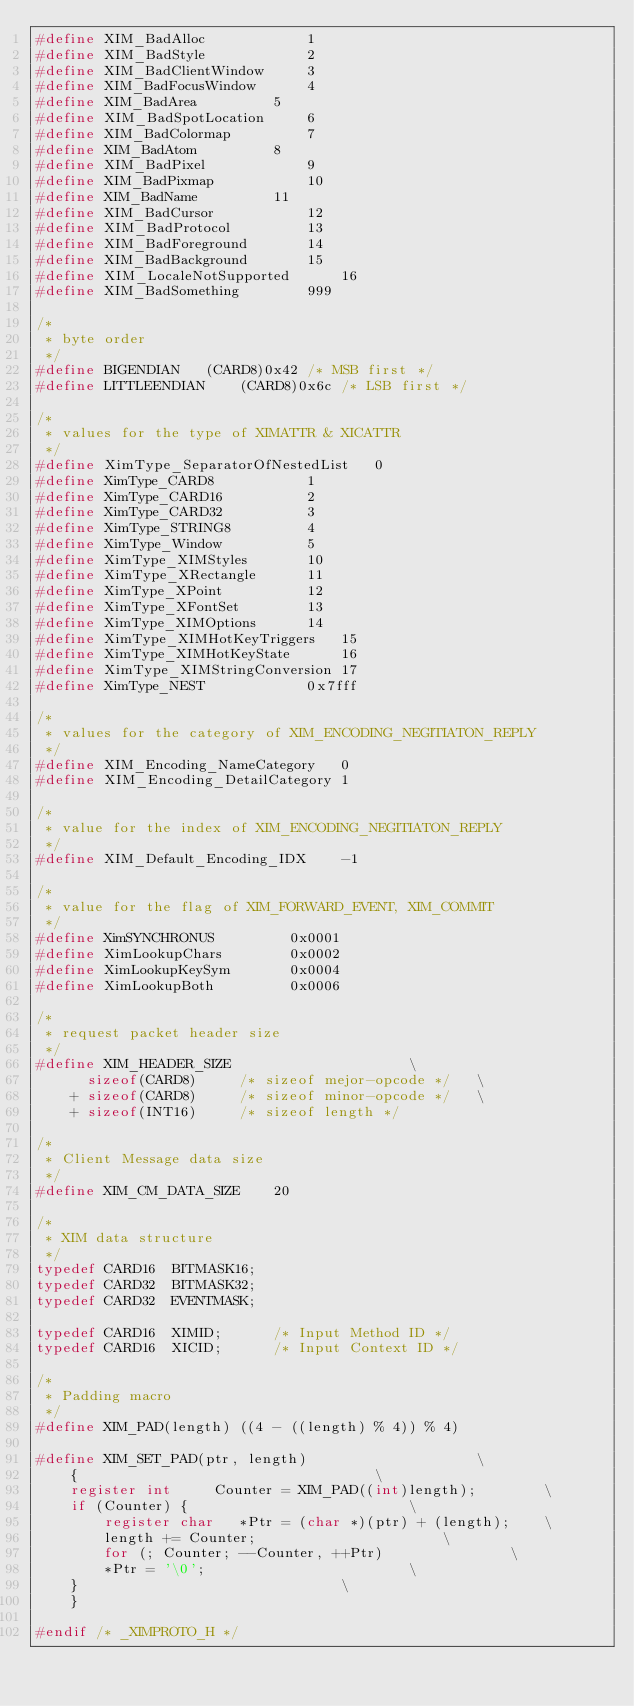<code> <loc_0><loc_0><loc_500><loc_500><_C_>#define XIM_BadAlloc			1
#define XIM_BadStyle			2
#define XIM_BadClientWindow		3
#define XIM_BadFocusWindow		4
#define XIM_BadArea			5
#define XIM_BadSpotLocation		6
#define XIM_BadColormap			7
#define XIM_BadAtom			8
#define XIM_BadPixel			9
#define XIM_BadPixmap			10
#define XIM_BadName			11
#define XIM_BadCursor			12
#define XIM_BadProtocol			13
#define XIM_BadForeground		14
#define XIM_BadBackground		15
#define XIM_LocaleNotSupported		16
#define XIM_BadSomething		999

/*
 * byte order
 */
#define BIGENDIAN	(CARD8)0x42	/* MSB first */
#define LITTLEENDIAN	(CARD8)0x6c	/* LSB first */

/*
 * values for the type of XIMATTR & XICATTR
 */
#define	XimType_SeparatorOfNestedList	0
#define	XimType_CARD8			1
#define	XimType_CARD16			2
#define	XimType_CARD32			3
#define	XimType_STRING8			4
#define	XimType_Window			5
#define	XimType_XIMStyles		10
#define	XimType_XRectangle		11
#define	XimType_XPoint			12
#define XimType_XFontSet		13
#define XimType_XIMOptions		14
#define XimType_XIMHotKeyTriggers	15
#define XimType_XIMHotKeyState		16
#define XimType_XIMStringConversion	17
#define	XimType_NEST			0x7fff

/*
 * values for the category of XIM_ENCODING_NEGITIATON_REPLY
 */
#define	XIM_Encoding_NameCategory	0
#define	XIM_Encoding_DetailCategory	1

/*
 * value for the index of XIM_ENCODING_NEGITIATON_REPLY
 */
#define	XIM_Default_Encoding_IDX	-1

/*
 * value for the flag of XIM_FORWARD_EVENT, XIM_COMMIT
 */
#define XimSYNCHRONUS		  0x0001
#define XimLookupChars		  0x0002
#define XimLookupKeySym		  0x0004
#define XimLookupBoth		  0x0006

/*
 * request packet header size
 */
#define XIM_HEADER_SIZE						\
	  sizeof(CARD8)		/* sizeof mejor-opcode */	\
	+ sizeof(CARD8)		/* sizeof minor-opcode */	\
	+ sizeof(INT16)		/* sizeof length */

/*
 * Client Message data size
 */
#define	XIM_CM_DATA_SIZE	20

/*
 * XIM data structure
 */
typedef CARD16	BITMASK16;
typedef CARD32	BITMASK32;
typedef CARD32	EVENTMASK;

typedef CARD16	XIMID;		/* Input Method ID */
typedef CARD16	XICID;		/* Input Context ID */

/*
 * Padding macro
 */
#define	XIM_PAD(length) ((4 - ((length) % 4)) % 4)

#define XIM_SET_PAD(ptr, length)					\
    {									\
	register int	 Counter = XIM_PAD((int)length);		\
	if (Counter) {							\
	    register char	*Ptr = (char *)(ptr) + (length);	\
	    length += Counter;						\
	    for (; Counter; --Counter, ++Ptr)				\
		*Ptr = '\0';						\
	}								\
    }

#endif /* _XIMPROTO_H */
</code> 